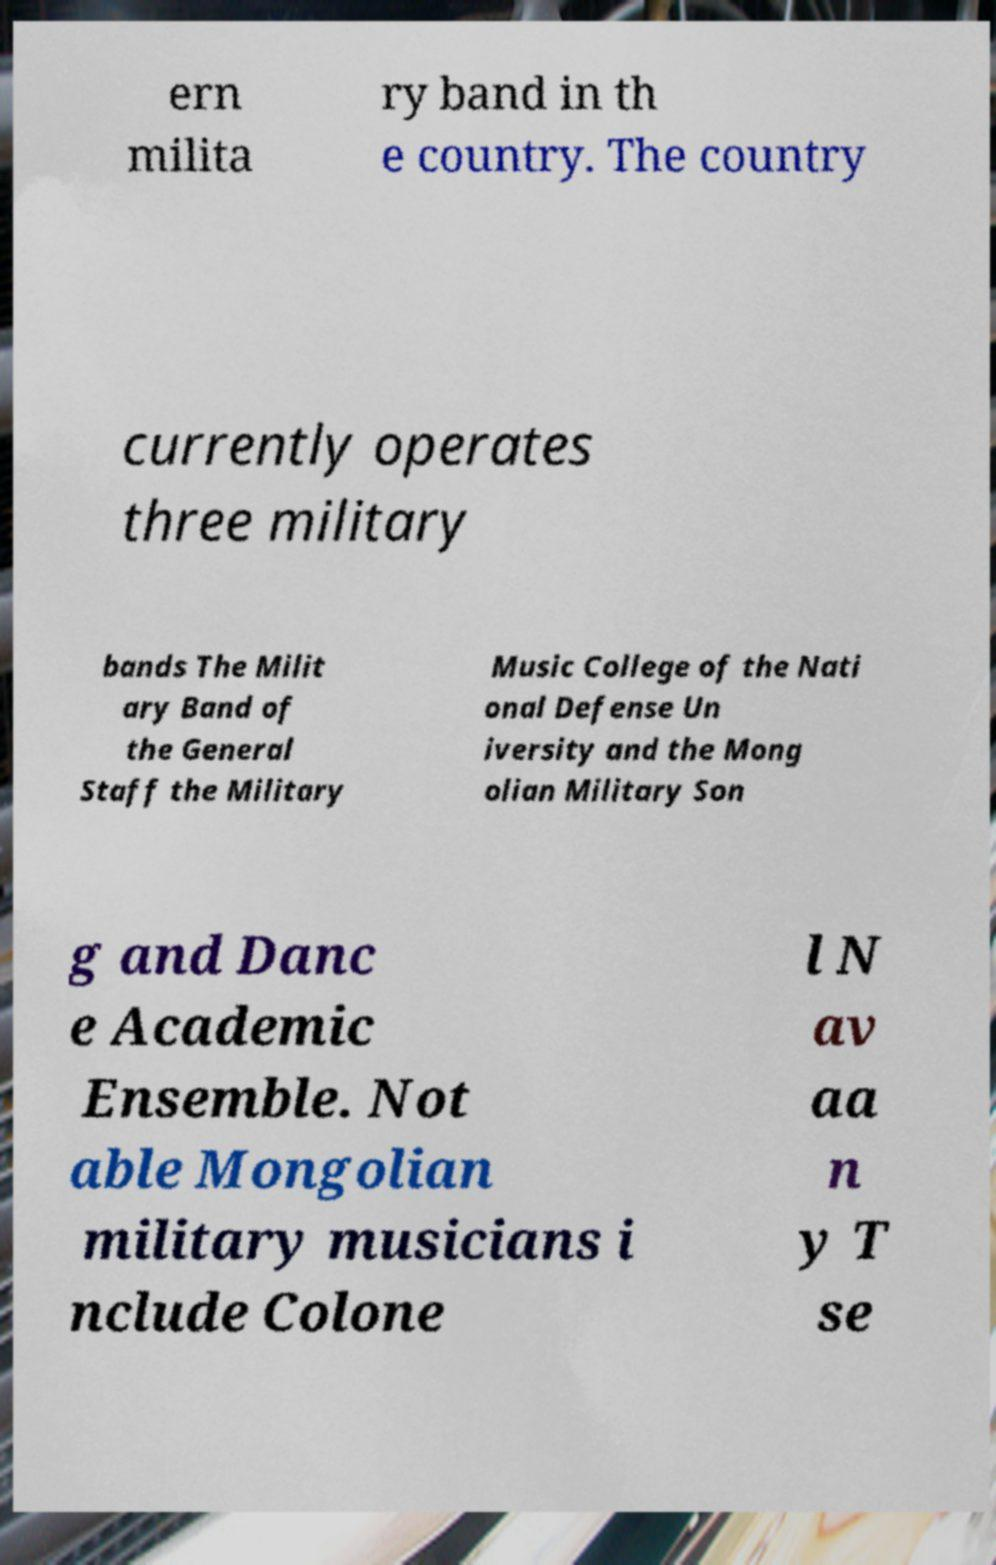Could you assist in decoding the text presented in this image and type it out clearly? ern milita ry band in th e country. The country currently operates three military bands The Milit ary Band of the General Staff the Military Music College of the Nati onal Defense Un iversity and the Mong olian Military Son g and Danc e Academic Ensemble. Not able Mongolian military musicians i nclude Colone l N av aa n y T se 